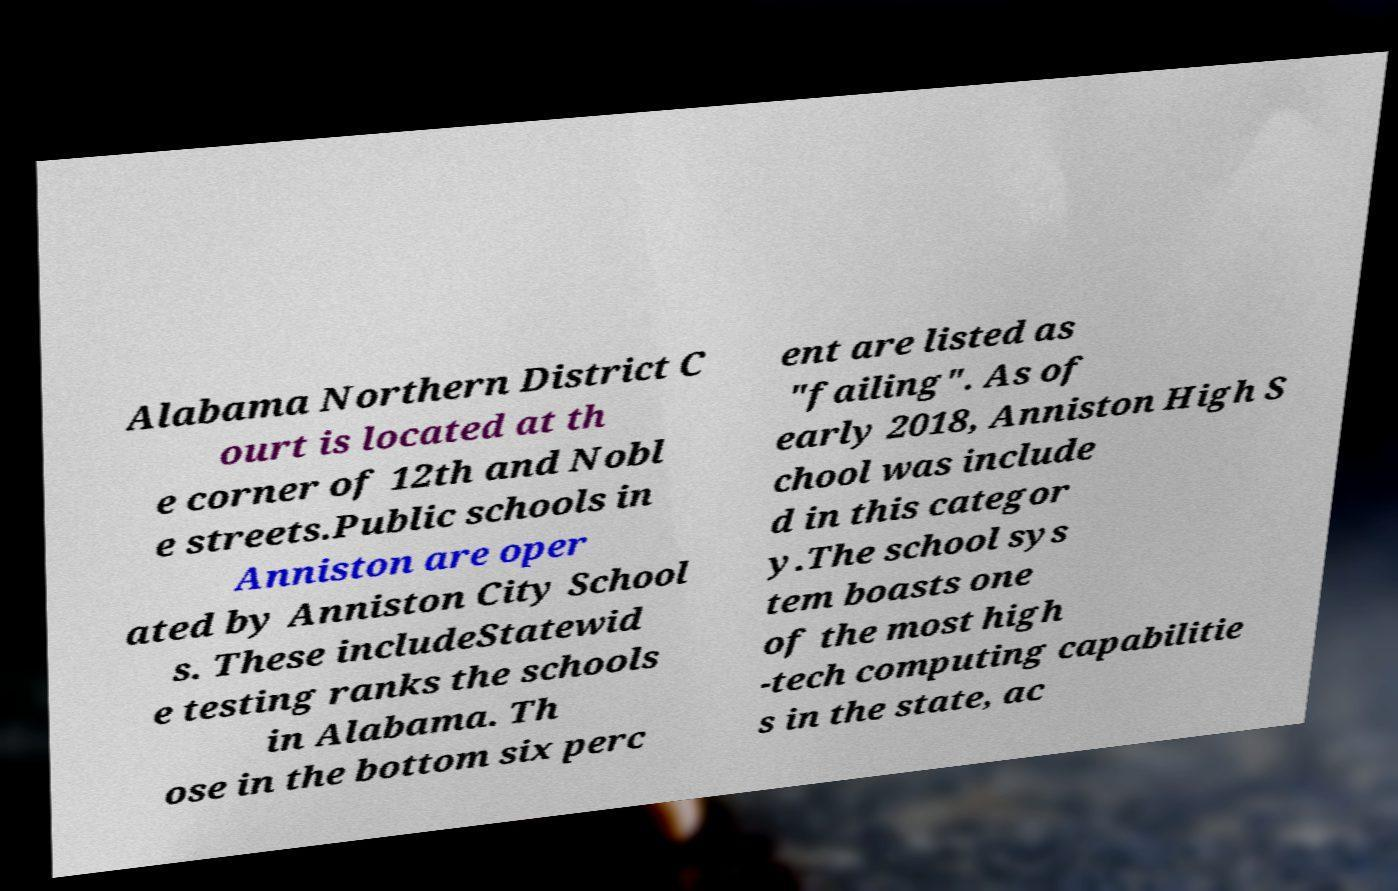Please read and relay the text visible in this image. What does it say? Alabama Northern District C ourt is located at th e corner of 12th and Nobl e streets.Public schools in Anniston are oper ated by Anniston City School s. These includeStatewid e testing ranks the schools in Alabama. Th ose in the bottom six perc ent are listed as "failing". As of early 2018, Anniston High S chool was include d in this categor y.The school sys tem boasts one of the most high -tech computing capabilitie s in the state, ac 